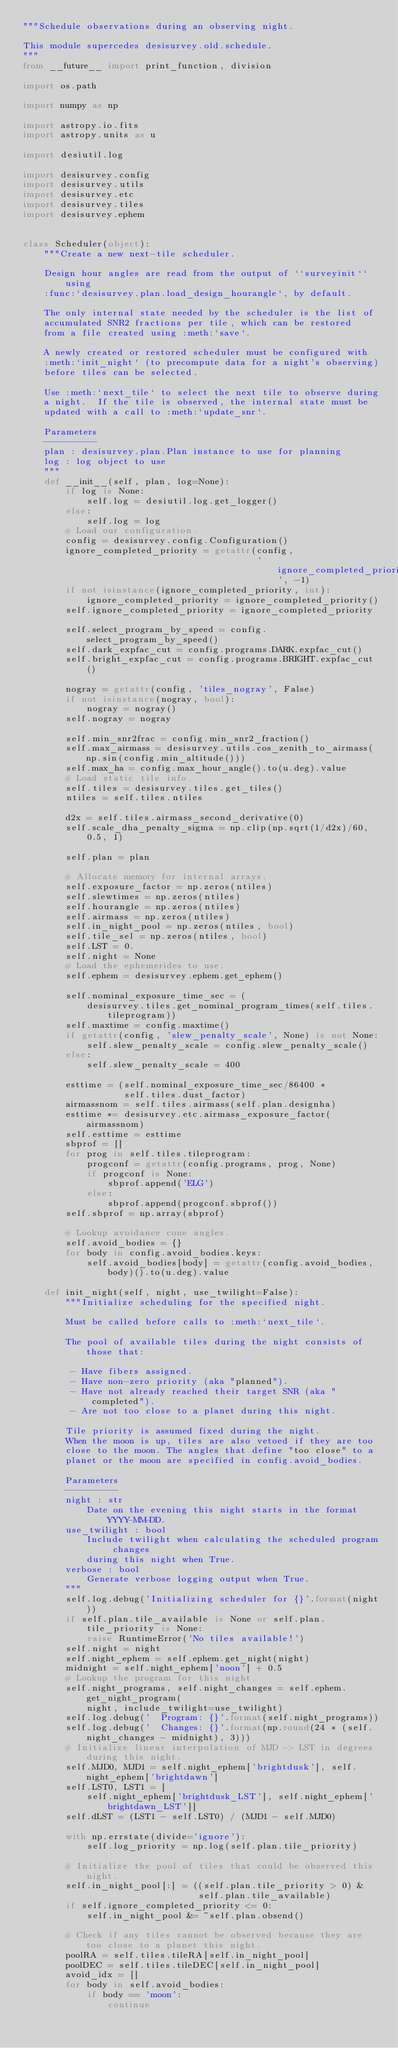Convert code to text. <code><loc_0><loc_0><loc_500><loc_500><_Python_>"""Schedule observations during an observing night.

This module supercedes desisurvey.old.schedule.
"""
from __future__ import print_function, division

import os.path

import numpy as np

import astropy.io.fits
import astropy.units as u

import desiutil.log

import desisurvey.config
import desisurvey.utils
import desisurvey.etc
import desisurvey.tiles
import desisurvey.ephem


class Scheduler(object):
    """Create a new next-tile scheduler.

    Design hour angles are read from the output of ``surveyinit`` using
    :func:`desisurvey.plan.load_design_hourangle`, by default.

    The only internal state needed by the scheduler is the list of
    accumulated SNR2 fractions per tile, which can be restored
    from a file created using :meth:`save`.

    A newly created or restored scheduler must be configured with
    :meth:`init_night` (to precompute data for a night's observing)
    before tiles can be selected.

    Use :meth:`next_tile` to select the next tile to observe during
    a night.  If the tile is observed, the internal state must be
    updated with a call to :meth:`update_snr`.

    Parameters
    ----------
    plan : desisurvey.plan.Plan instance to use for planning
    log : log object to use
    """
    def __init__(self, plan, log=None):
        if log is None:
            self.log = desiutil.log.get_logger()
        else:
            self.log = log
        # Load our configuration.
        config = desisurvey.config.Configuration()
        ignore_completed_priority = getattr(config,
                                            'ignore_completed_priority', -1)
        if not isinstance(ignore_completed_priority, int):
            ignore_completed_priority = ignore_completed_priority()
        self.ignore_completed_priority = ignore_completed_priority

        self.select_program_by_speed = config.select_program_by_speed()
        self.dark_expfac_cut = config.programs.DARK.expfac_cut()
        self.bright_expfac_cut = config.programs.BRIGHT.expfac_cut()

        nogray = getattr(config, 'tiles_nogray', False)
        if not isinstance(nogray, bool):
            nogray = nogray()
        self.nogray = nogray

        self.min_snr2frac = config.min_snr2_fraction()
        self.max_airmass = desisurvey.utils.cos_zenith_to_airmass(np.sin(config.min_altitude()))
        self.max_ha = config.max_hour_angle().to(u.deg).value
        # Load static tile info.
        self.tiles = desisurvey.tiles.get_tiles()
        ntiles = self.tiles.ntiles

        d2x = self.tiles.airmass_second_derivative(0)
        self.scale_dha_penalty_sigma = np.clip(np.sqrt(1/d2x)/60, 0.5, 1)

        self.plan = plan

        # Allocate memory for internal arrays.
        self.exposure_factor = np.zeros(ntiles)
        self.slewtimes = np.zeros(ntiles)
        self.hourangle = np.zeros(ntiles)
        self.airmass = np.zeros(ntiles)
        self.in_night_pool = np.zeros(ntiles, bool)
        self.tile_sel = np.zeros(ntiles, bool)
        self.LST = 0.
        self.night = None
        # Load the ephemerides to use.
        self.ephem = desisurvey.ephem.get_ephem()

        self.nominal_exposure_time_sec = (
            desisurvey.tiles.get_nominal_program_times(self.tiles.tileprogram))
        self.maxtime = config.maxtime()
        if getattr(config, 'slew_penalty_scale', None) is not None:
            self.slew_penalty_scale = config.slew_penalty_scale()
        else:
            self.slew_penalty_scale = 400

        esttime = (self.nominal_exposure_time_sec/86400 *
                   self.tiles.dust_factor)
        airmassnom = self.tiles.airmass(self.plan.designha)
        esttime *= desisurvey.etc.airmass_exposure_factor(airmassnom)
        self.esttime = esttime
        sbprof = []
        for prog in self.tiles.tileprogram:
            progconf = getattr(config.programs, prog, None)
            if progconf is None:
                sbprof.append('ELG')
            else:
                sbprof.append(progconf.sbprof())
        self.sbprof = np.array(sbprof)

        # Lookup avoidance cone angles.
        self.avoid_bodies = {}
        for body in config.avoid_bodies.keys:
            self.avoid_bodies[body] = getattr(config.avoid_bodies, body)().to(u.deg).value

    def init_night(self, night, use_twilight=False):
        """Initialize scheduling for the specified night.

        Must be called before calls to :meth:`next_tile`.

        The pool of available tiles during the night consists of those that:

         - Have fibers assigned.
         - Have non-zero priority (aka "planned").
         - Have not already reached their target SNR (aka "completed").
         - Are not too close to a planet during this night.

        Tile priority is assumed fixed during the night.
        When the moon is up, tiles are also vetoed if they are too
        close to the moon. The angles that define "too close" to a
        planet or the moon are specified in config.avoid_bodies.

        Parameters
        ----------
        night : str
            Date on the evening this night starts in the format YYYY-MM-DD.
        use_twilight : bool
            Include twilight when calculating the scheduled program changes
            during this night when True.
        verbose : bool
            Generate verbose logging output when True.
        """
        self.log.debug('Initializing scheduler for {}'.format(night))
        if self.plan.tile_available is None or self.plan.tile_priority is None:
            raise RuntimeError('No tiles available!')
        self.night = night
        self.night_ephem = self.ephem.get_night(night)
        midnight = self.night_ephem['noon'] + 0.5
        # Lookup the program for this night.
        self.night_programs, self.night_changes = self.ephem.get_night_program(
            night, include_twilight=use_twilight)
        self.log.debug('  Program: {}'.format(self.night_programs))
        self.log.debug('  Changes: {}'.format(np.round(24 * (self.night_changes - midnight), 3)))
        # Initialize linear interpolation of MJD -> LST in degrees during this night.
        self.MJD0, MJD1 = self.night_ephem['brightdusk'], self.night_ephem['brightdawn']
        self.LST0, LST1 = [
            self.night_ephem['brightdusk_LST'], self.night_ephem['brightdawn_LST']]
        self.dLST = (LST1 - self.LST0) / (MJD1 - self.MJD0)

        with np.errstate(divide='ignore'):
            self.log_priority = np.log(self.plan.tile_priority)

        # Initialize the pool of tiles that could be observed this night.
        self.in_night_pool[:] = ((self.plan.tile_priority > 0) &
                                 self.plan.tile_available)
        if self.ignore_completed_priority <= 0:
            self.in_night_pool &= ~self.plan.obsend()

        # Check if any tiles cannot be observed because they are too close to a planet this night.
        poolRA = self.tiles.tileRA[self.in_night_pool]
        poolDEC = self.tiles.tileDEC[self.in_night_pool]
        avoid_idx = []
        for body in self.avoid_bodies:
            if body == 'moon':
                continue</code> 